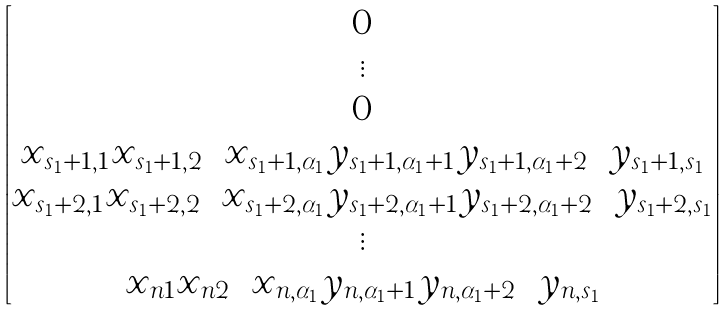<formula> <loc_0><loc_0><loc_500><loc_500>\begin{bmatrix} 0 \\ \vdots \\ 0 \\ x _ { s _ { 1 } + 1 , 1 } x _ { s _ { 1 } + 1 , 2 } \cdots x _ { s _ { 1 } + 1 , \alpha _ { 1 } } y _ { s _ { 1 } + 1 , \alpha _ { 1 } + 1 } y _ { s _ { 1 } + 1 , \alpha _ { 1 } + 2 } \cdots y _ { s _ { 1 } + 1 , s _ { 1 } } \\ x _ { s _ { 1 } + 2 , 1 } x _ { s _ { 1 } + 2 , 2 } \cdots x _ { s _ { 1 } + 2 , \alpha _ { 1 } } y _ { s _ { 1 } + 2 , \alpha _ { 1 } + 1 } y _ { s _ { 1 } + 2 , \alpha _ { 1 } + 2 } \cdots y _ { s _ { 1 } + 2 , s _ { 1 } } \\ \vdots \\ x _ { n 1 } x _ { n 2 } \cdots x _ { n , \alpha _ { 1 } } y _ { n , \alpha _ { 1 } + 1 } y _ { n , \alpha _ { 1 } + 2 } \cdots y _ { n , s _ { 1 } } \end{bmatrix}</formula> 